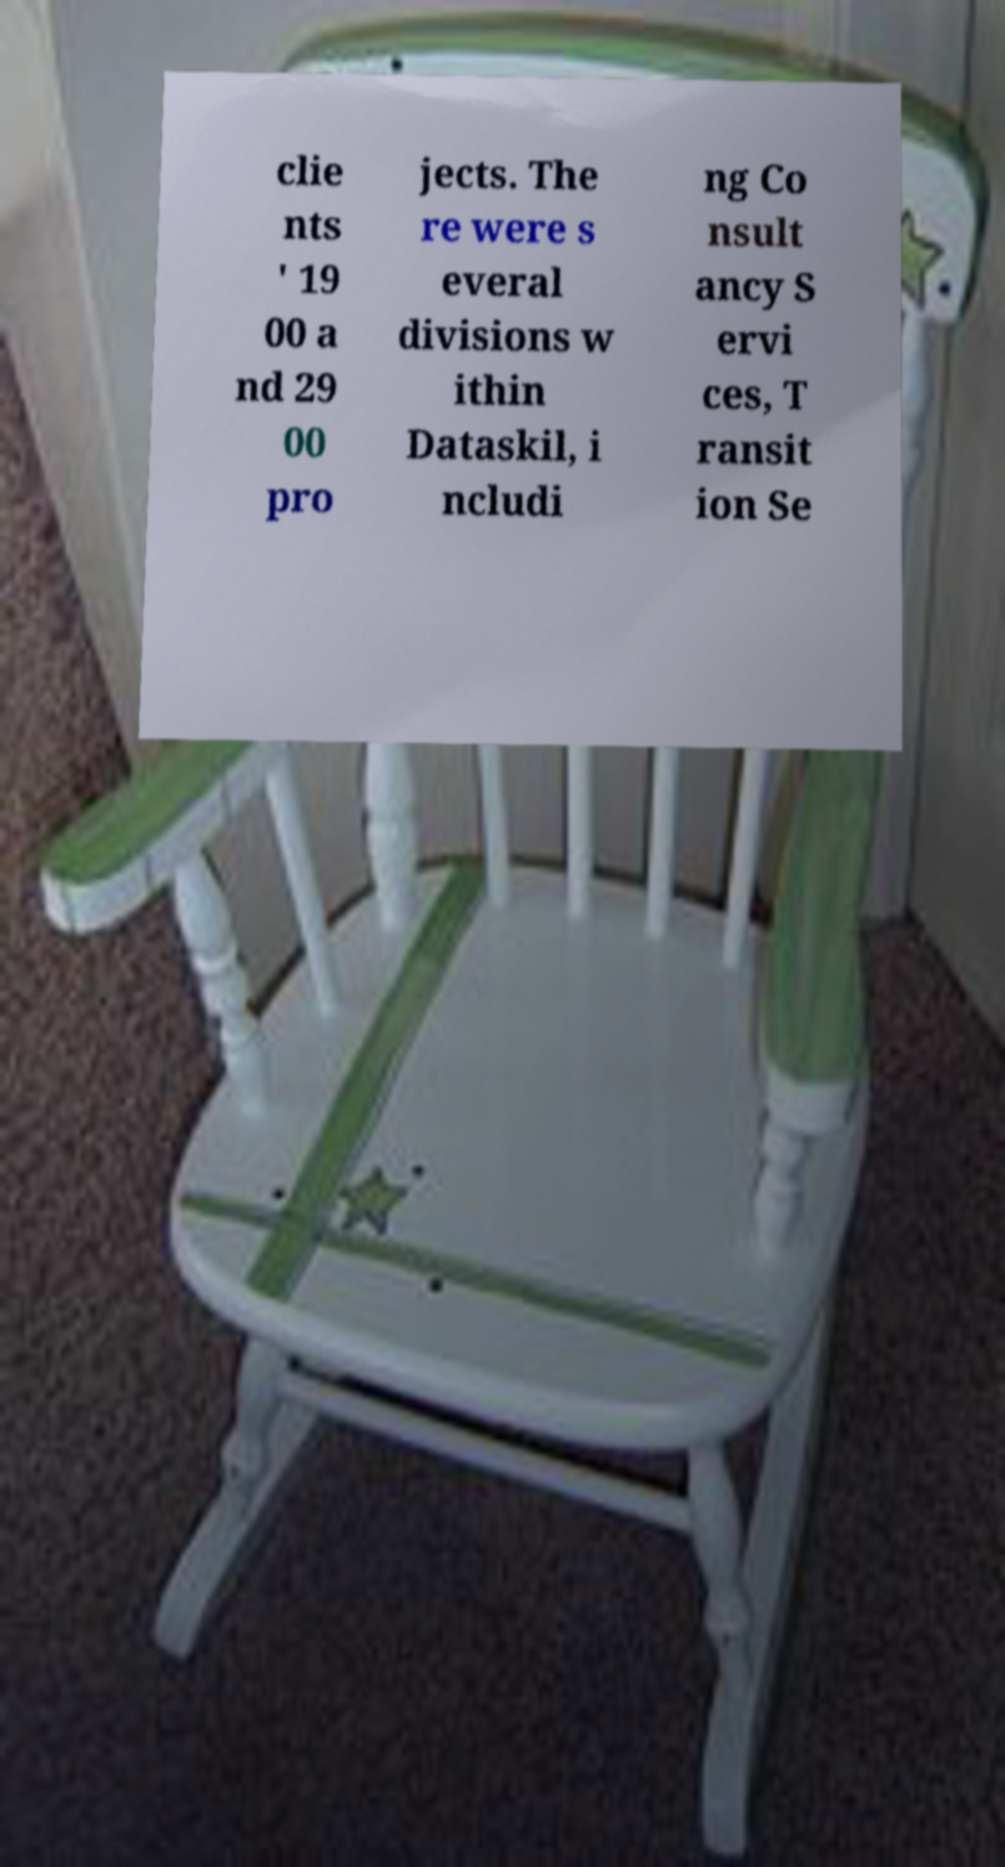Could you assist in decoding the text presented in this image and type it out clearly? clie nts ' 19 00 a nd 29 00 pro jects. The re were s everal divisions w ithin Dataskil, i ncludi ng Co nsult ancy S ervi ces, T ransit ion Se 